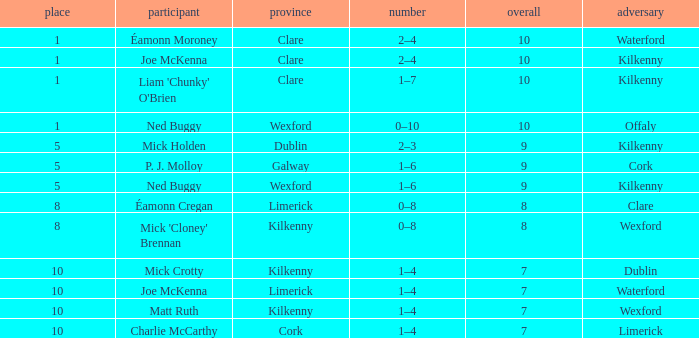Which County has a Rank larger than 8, and a Player of joe mckenna? Limerick. 